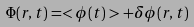Convert formula to latex. <formula><loc_0><loc_0><loc_500><loc_500>\Phi ( r , t ) = < \phi ( t ) > + \delta \phi ( r , t )</formula> 